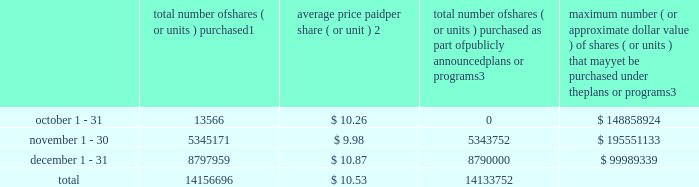Repurchase of equity securities the table provides information regarding our purchases of our equity securities during the period from october 1 , 2012 to december 31 , 2012 .
Total number of shares ( or units ) purchased 1 average price paid per share ( or unit ) 2 total number of shares ( or units ) purchased as part of publicly announced plans or programs 3 maximum number ( or approximate dollar value ) of shares ( or units ) that may yet be purchased under the plans or programs 3 .
1 includes shares of our common stock , par value $ 0.10 per share , withheld under the terms of grants under employee stock-based compensation plans to offset tax withholding obligations that occurred upon vesting and release of restricted shares ( the 201cwithheld shares 201d ) .
We repurchased 13566 withheld shares in october 2012 , 1419 withheld shares in november 2012 and 7959 withheld shares in december 2012 , for a total of 22944 withheld shares during the three-month period .
2 the average price per share for each of the months in the fiscal quarter and for the three-month period was calculated by dividing the sum of the applicable period of the aggregate value of the tax withholding obligations and the aggregate amount we paid for shares acquired under our stock repurchase program , described in note 5 to the consolidated financial statements , by the sum of the number of withheld shares and the number of shares acquired in our stock repurchase program .
3 on february 24 , 2012 , we announced in a press release that our board had approved a share repurchase program to repurchase from time to time up to $ 300.0 million of our common stock ( the 201c2012 share repurchase program 201d ) , in addition to amounts available on existing authorizations .
On november 20 , 2012 , we announced in a press release that our board had authorized an increase in our 2012 share repurchase program to $ 400.0 million of our common stock .
On february 22 , 2013 , we announced that our board had approved a new share repurchase program to repurchase from time to time up to $ 300.0 million of our common stock .
The new authorization is in addition to any amounts remaining available for repurchase under the 2012 share repurchase program .
There is no expiration date associated with the share repurchase programs. .
What was the percent of the withheld shares repurchased in october during the three-month period? 
Computations: (13566 / 22944)
Answer: 0.59127. 